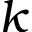<formula> <loc_0><loc_0><loc_500><loc_500>k</formula> 